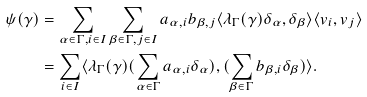<formula> <loc_0><loc_0><loc_500><loc_500>\psi ( \gamma ) & = \sum _ { \alpha \in \Gamma , i \in I } \sum _ { \beta \in \Gamma , j \in I } a _ { \alpha , i } b _ { \beta , j } \langle \lambda _ { \Gamma } ( \gamma ) \delta _ { \alpha } , \delta _ { \beta } \rangle \langle v _ { i } , v _ { j } \rangle \\ & = \sum _ { i \in I } \langle \lambda _ { \Gamma } ( \gamma ) ( \sum _ { \alpha \in \Gamma } a _ { \alpha , i } \delta _ { \alpha } ) , ( \sum _ { \beta \in \Gamma } b _ { \beta , i } \delta _ { \beta } ) \rangle .</formula> 